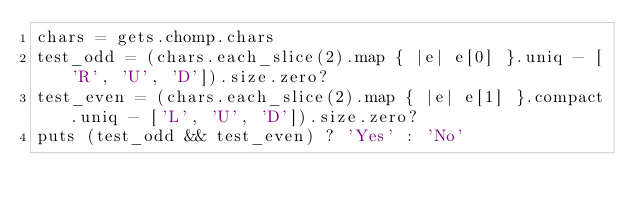Convert code to text. <code><loc_0><loc_0><loc_500><loc_500><_Ruby_>chars = gets.chomp.chars
test_odd = (chars.each_slice(2).map { |e| e[0] }.uniq - ['R', 'U', 'D']).size.zero?
test_even = (chars.each_slice(2).map { |e| e[1] }.compact.uniq - ['L', 'U', 'D']).size.zero?
puts (test_odd && test_even) ? 'Yes' : 'No'
</code> 